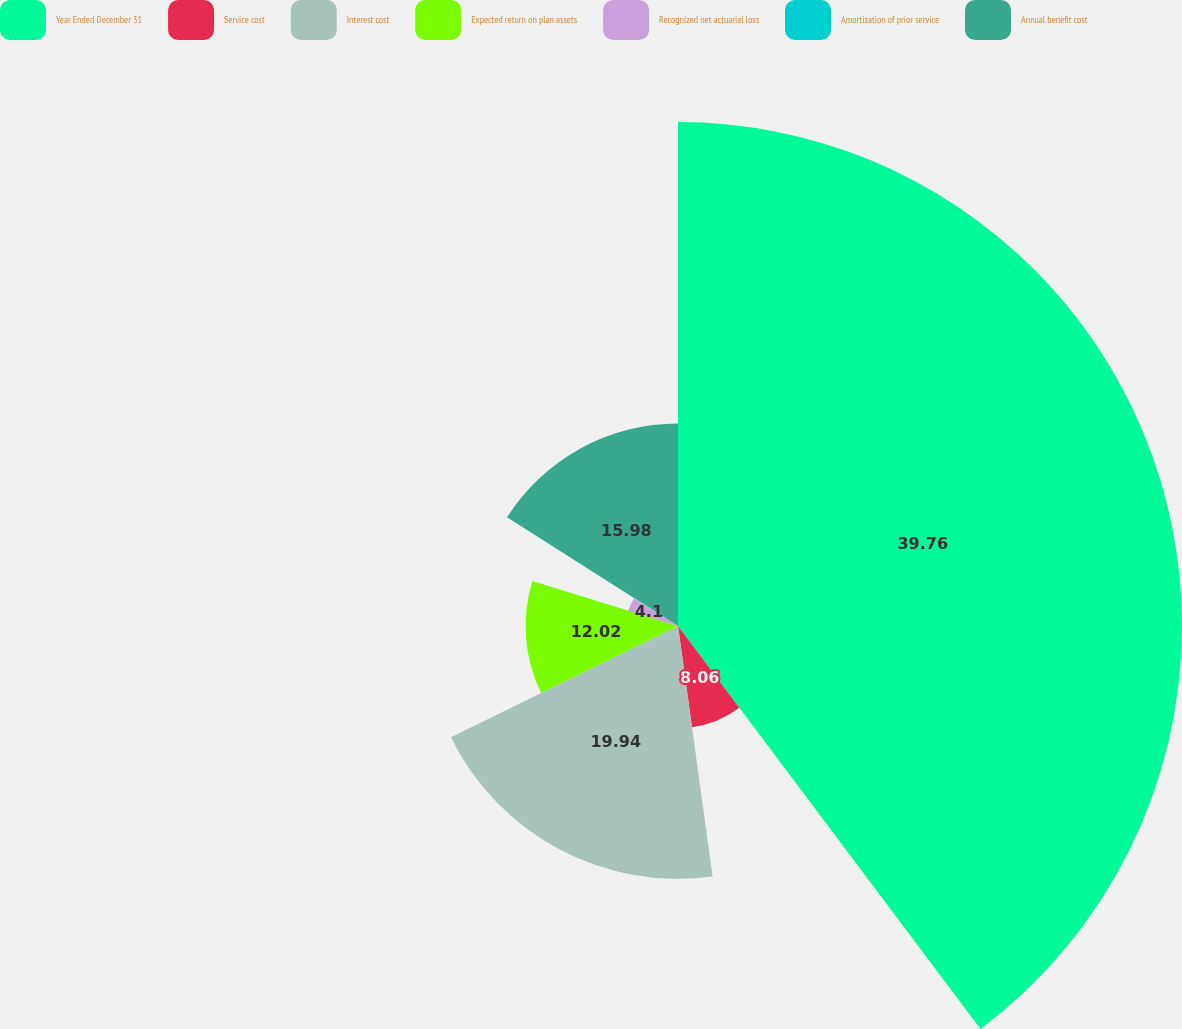<chart> <loc_0><loc_0><loc_500><loc_500><pie_chart><fcel>Year Ended December 31<fcel>Service cost<fcel>Interest cost<fcel>Expected return on plan assets<fcel>Recognized net actuarial loss<fcel>Amortization of prior service<fcel>Annual benefit cost<nl><fcel>39.75%<fcel>8.06%<fcel>19.94%<fcel>12.02%<fcel>4.1%<fcel>0.14%<fcel>15.98%<nl></chart> 